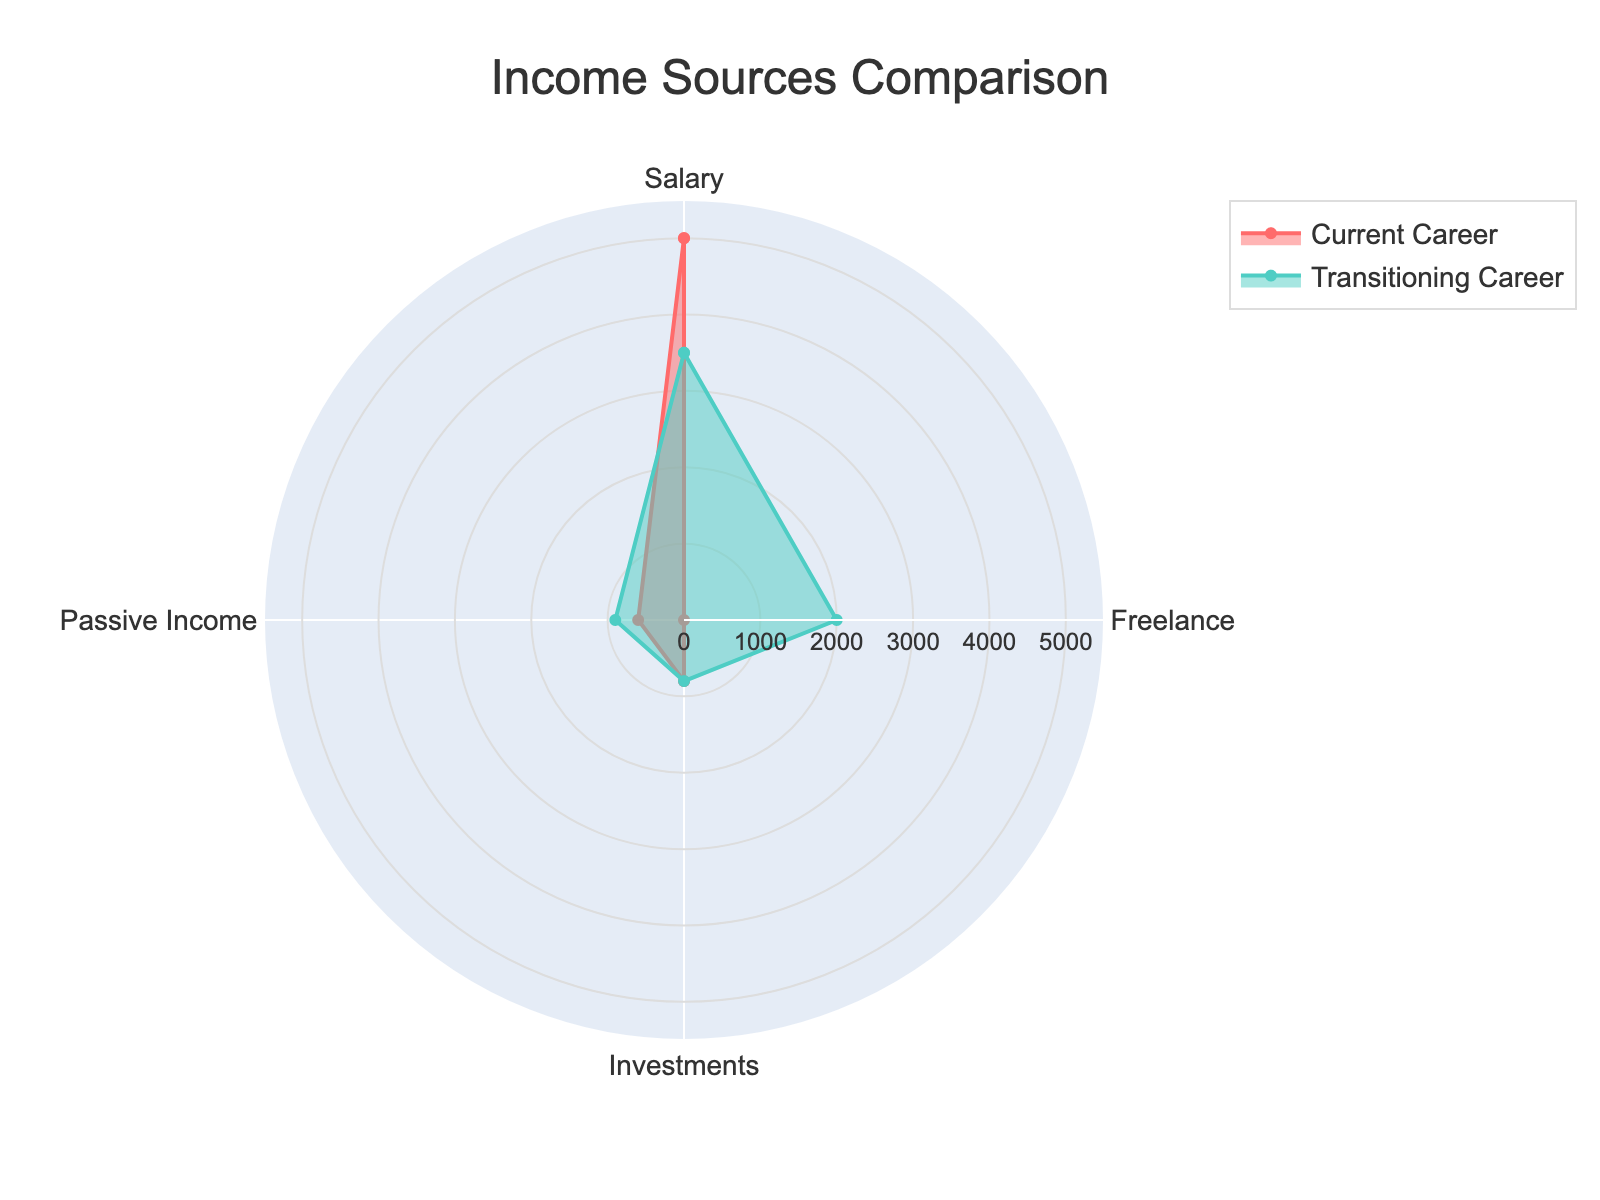What is the title of the radar chart? The title is displayed at the top of the radar chart, typically in a larger and bold font compared to other texts in the figure.
Answer: Income Sources Comparison Which income source has the highest value in your current career? By examining the current career trace, the highest value point on the radar chart is the one with the longest distance from the center.
Answer: Salary How does passive income compare between your current and transitioning careers? Compare the length of the passive income segment from the center for both the current and transitioning career traces.
Answer: Transitioning career has higher passive income What is the total income from all sources in your transitioning career? Sum the transitioning career values for all income sources: (3500 + 2000 + 800 + 900).
Answer: 7200 Which career has a higher proportion of income from freelance work? Observe the radar chart segments and note that the transitioning career trace has a significant value for freelance, while the current career trace has zero.
Answer: Transitioning career What is the difference in salary income between your current and transitioning careers? Subtract the transitioning career's salary value from the current career's salary value: 5000 - 3500.
Answer: 1500 How much did your total passive and investment income change between careers? Calculate the total passive and investment income for both careers and find the difference: (800+600) for current, (800+900) for transitioning. Difference is 1400 - 1400.
Answer: Increased by 300 Is the transitioning career more diversified in income sources compared to the current career? By visually comparing the areas covered under each trace, the transitioning career has significant values in three out of four sources, compared to the current career which has zero value in freelance.
Answer: Yes How do the maximum values in current and transitioning careers compare? Identify the highest value point on each trace and compare them: 5000 for current (salary) and 3500 for transitioning (salary).
Answer: Current career's maximum is higher 